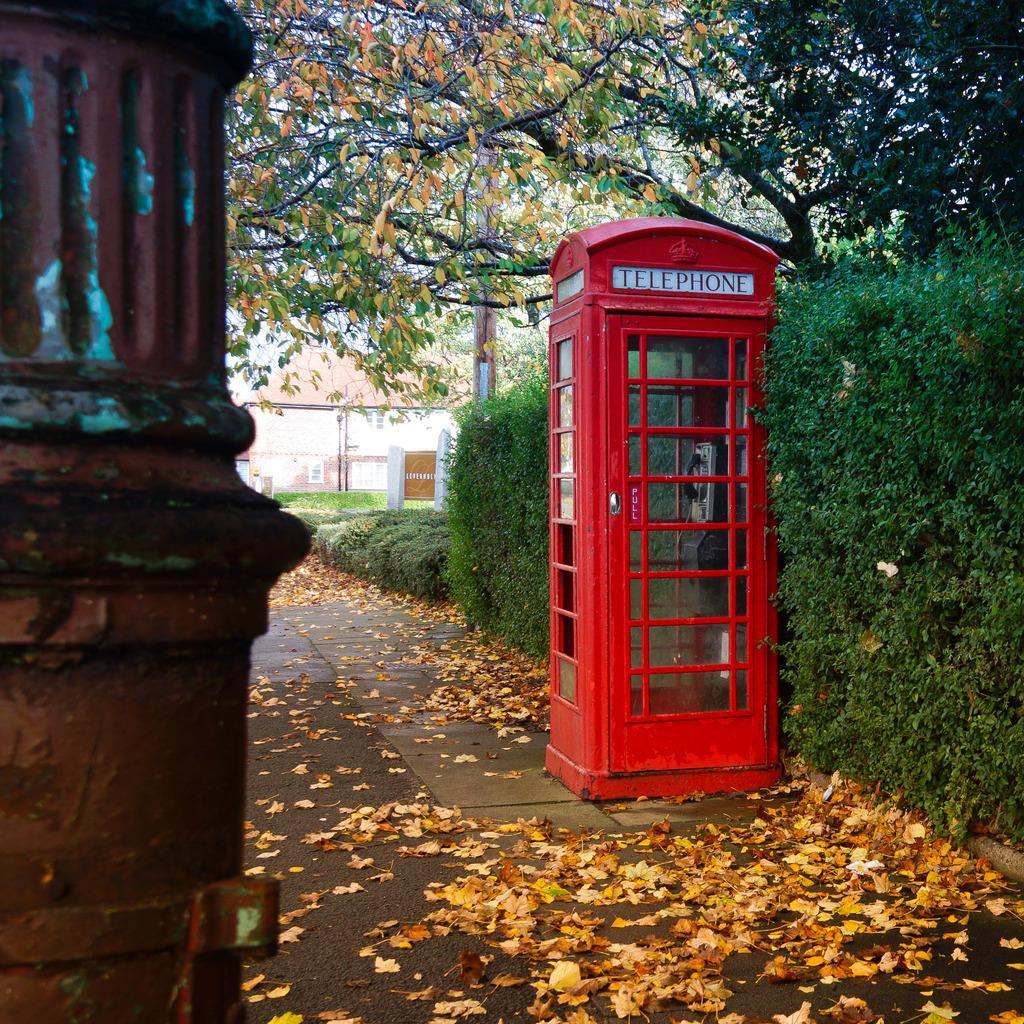How would you summarize this image in a sentence or two? In the picture I can see an object in the left corner and there is a telephone booth and few plants behind it in the right corner and there are trees and a building in the background. 